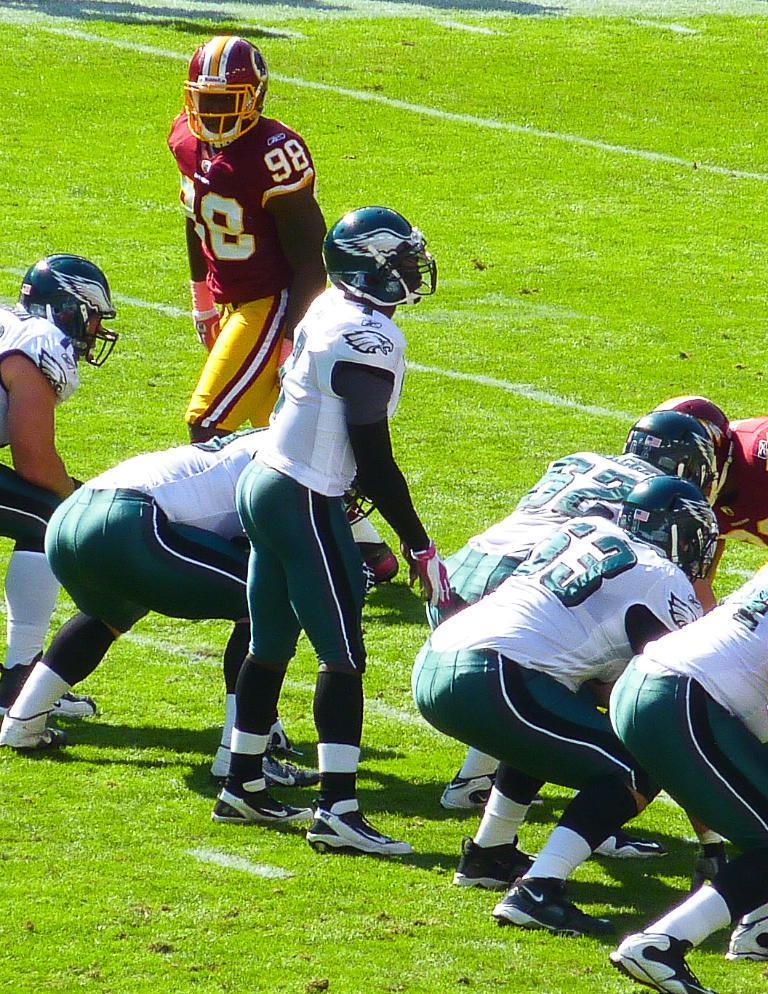Please provide a concise description of this image. In this image there are few players playing on a playground. 